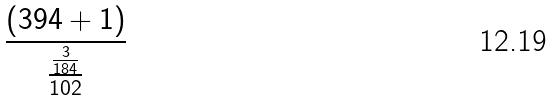Convert formula to latex. <formula><loc_0><loc_0><loc_500><loc_500>\frac { ( 3 9 4 + 1 ) } { \frac { \frac { 3 } { 1 8 4 } } { 1 0 2 } }</formula> 